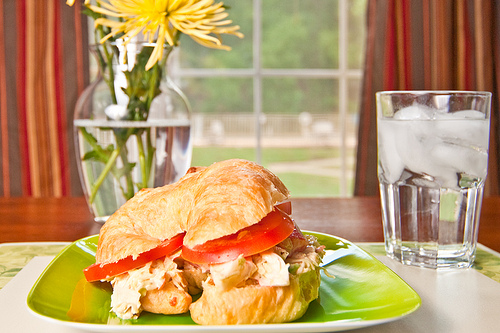Which kind of food is on the plate? The food on the plate is a sandwich, specifically a croissant sandwich filled with chicken and tomato. 